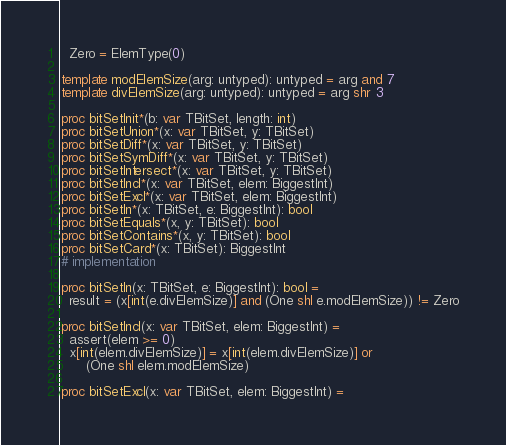Convert code to text. <code><loc_0><loc_0><loc_500><loc_500><_Nim_>  Zero = ElemType(0)

template modElemSize(arg: untyped): untyped = arg and 7
template divElemSize(arg: untyped): untyped = arg shr 3

proc bitSetInit*(b: var TBitSet, length: int)
proc bitSetUnion*(x: var TBitSet, y: TBitSet)
proc bitSetDiff*(x: var TBitSet, y: TBitSet)
proc bitSetSymDiff*(x: var TBitSet, y: TBitSet)
proc bitSetIntersect*(x: var TBitSet, y: TBitSet)
proc bitSetIncl*(x: var TBitSet, elem: BiggestInt)
proc bitSetExcl*(x: var TBitSet, elem: BiggestInt)
proc bitSetIn*(x: TBitSet, e: BiggestInt): bool
proc bitSetEquals*(x, y: TBitSet): bool
proc bitSetContains*(x, y: TBitSet): bool
proc bitSetCard*(x: TBitSet): BiggestInt
# implementation

proc bitSetIn(x: TBitSet, e: BiggestInt): bool =
  result = (x[int(e.divElemSize)] and (One shl e.modElemSize)) != Zero

proc bitSetIncl(x: var TBitSet, elem: BiggestInt) =
  assert(elem >= 0)
  x[int(elem.divElemSize)] = x[int(elem.divElemSize)] or
      (One shl elem.modElemSize)

proc bitSetExcl(x: var TBitSet, elem: BiggestInt) =</code> 